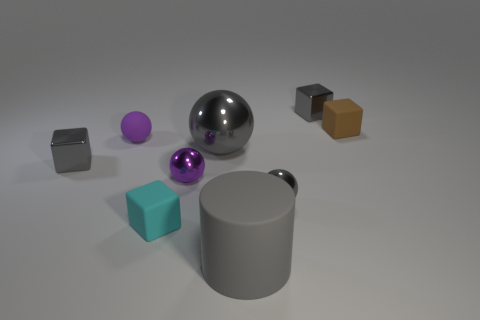Do the cylinder and the big gray object behind the big gray matte object have the same material?
Provide a short and direct response. No. There is a object behind the matte block behind the purple thing that is in front of the purple rubber sphere; what is its material?
Offer a very short reply. Metal. The large ball is what color?
Your response must be concise. Gray. How many tiny metallic things are the same color as the big matte cylinder?
Offer a very short reply. 3. There is a brown object that is the same size as the cyan block; what material is it?
Provide a short and direct response. Rubber. There is a tiny gray object on the left side of the large gray matte cylinder; are there any tiny metallic blocks to the right of it?
Provide a succinct answer. Yes. What number of other things are the same color as the big metal thing?
Make the answer very short. 4. The cyan rubber cube is what size?
Offer a very short reply. Small. Is there a rubber object?
Offer a terse response. Yes. Are there more cyan blocks that are to the left of the cyan thing than big gray matte cylinders that are to the left of the brown block?
Make the answer very short. No. 